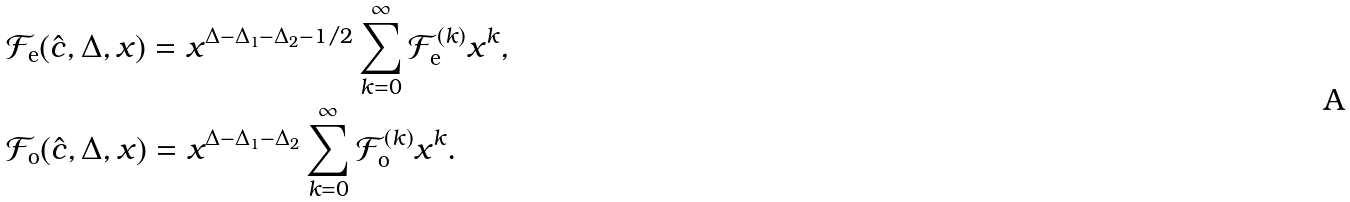Convert formula to latex. <formula><loc_0><loc_0><loc_500><loc_500>& \mathcal { F } _ { \text {e} } ( \hat { c } , \Delta , x ) = x ^ { \Delta - \Delta _ { 1 } - \Delta _ { 2 } - 1 / 2 } \sum _ { k = 0 } ^ { \infty } \mathcal { F } _ { \text {e} } ^ { ( k ) } x ^ { k } , \\ & \mathcal { F } _ { \text {o} } ( \hat { c } , \Delta , x ) = x ^ { \Delta - \Delta _ { 1 } - \Delta _ { 2 } } \sum _ { k = 0 } ^ { \infty } \mathcal { F } _ { \text {o} } ^ { ( k ) } x ^ { k } .</formula> 